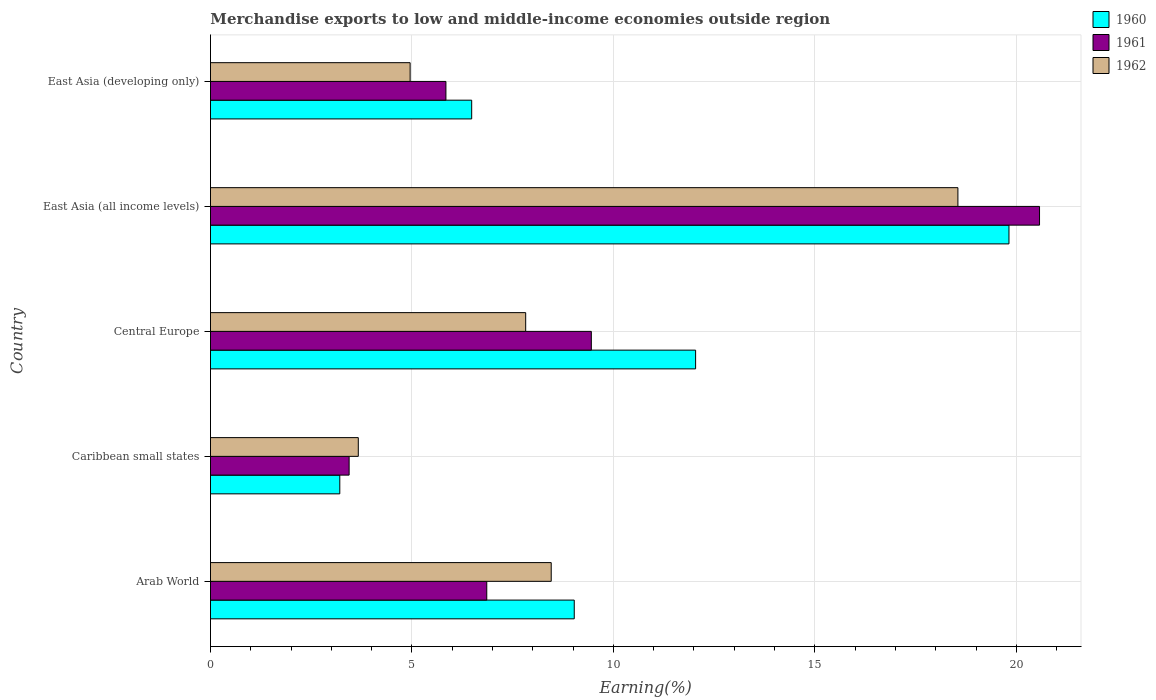How many different coloured bars are there?
Make the answer very short. 3. How many groups of bars are there?
Ensure brevity in your answer.  5. Are the number of bars on each tick of the Y-axis equal?
Your answer should be compact. Yes. What is the label of the 5th group of bars from the top?
Your response must be concise. Arab World. What is the percentage of amount earned from merchandise exports in 1961 in Caribbean small states?
Your answer should be compact. 3.44. Across all countries, what is the maximum percentage of amount earned from merchandise exports in 1962?
Make the answer very short. 18.55. Across all countries, what is the minimum percentage of amount earned from merchandise exports in 1962?
Ensure brevity in your answer.  3.67. In which country was the percentage of amount earned from merchandise exports in 1960 maximum?
Keep it short and to the point. East Asia (all income levels). In which country was the percentage of amount earned from merchandise exports in 1960 minimum?
Offer a terse response. Caribbean small states. What is the total percentage of amount earned from merchandise exports in 1960 in the graph?
Offer a very short reply. 50.58. What is the difference between the percentage of amount earned from merchandise exports in 1960 in Caribbean small states and that in East Asia (developing only)?
Offer a terse response. -3.27. What is the difference between the percentage of amount earned from merchandise exports in 1960 in Arab World and the percentage of amount earned from merchandise exports in 1961 in East Asia (developing only)?
Offer a terse response. 3.19. What is the average percentage of amount earned from merchandise exports in 1962 per country?
Make the answer very short. 8.69. What is the difference between the percentage of amount earned from merchandise exports in 1960 and percentage of amount earned from merchandise exports in 1962 in East Asia (developing only)?
Offer a very short reply. 1.53. What is the ratio of the percentage of amount earned from merchandise exports in 1960 in East Asia (all income levels) to that in East Asia (developing only)?
Give a very brief answer. 3.06. Is the difference between the percentage of amount earned from merchandise exports in 1960 in Arab World and East Asia (developing only) greater than the difference between the percentage of amount earned from merchandise exports in 1962 in Arab World and East Asia (developing only)?
Your response must be concise. No. What is the difference between the highest and the second highest percentage of amount earned from merchandise exports in 1962?
Provide a succinct answer. 10.09. What is the difference between the highest and the lowest percentage of amount earned from merchandise exports in 1960?
Offer a terse response. 16.61. What does the 1st bar from the top in Arab World represents?
Your answer should be compact. 1962. Is it the case that in every country, the sum of the percentage of amount earned from merchandise exports in 1960 and percentage of amount earned from merchandise exports in 1962 is greater than the percentage of amount earned from merchandise exports in 1961?
Make the answer very short. Yes. How many bars are there?
Your answer should be compact. 15. Are all the bars in the graph horizontal?
Provide a short and direct response. Yes. What is the difference between two consecutive major ticks on the X-axis?
Make the answer very short. 5. Are the values on the major ticks of X-axis written in scientific E-notation?
Offer a very short reply. No. Does the graph contain any zero values?
Keep it short and to the point. No. How are the legend labels stacked?
Give a very brief answer. Vertical. What is the title of the graph?
Offer a terse response. Merchandise exports to low and middle-income economies outside region. What is the label or title of the X-axis?
Your answer should be very brief. Earning(%). What is the Earning(%) of 1960 in Arab World?
Provide a short and direct response. 9.03. What is the Earning(%) of 1961 in Arab World?
Your response must be concise. 6.86. What is the Earning(%) of 1962 in Arab World?
Provide a succinct answer. 8.46. What is the Earning(%) of 1960 in Caribbean small states?
Your answer should be very brief. 3.21. What is the Earning(%) of 1961 in Caribbean small states?
Keep it short and to the point. 3.44. What is the Earning(%) of 1962 in Caribbean small states?
Provide a short and direct response. 3.67. What is the Earning(%) in 1960 in Central Europe?
Offer a very short reply. 12.04. What is the Earning(%) of 1961 in Central Europe?
Provide a succinct answer. 9.45. What is the Earning(%) of 1962 in Central Europe?
Your answer should be compact. 7.82. What is the Earning(%) in 1960 in East Asia (all income levels)?
Give a very brief answer. 19.82. What is the Earning(%) of 1961 in East Asia (all income levels)?
Offer a terse response. 20.58. What is the Earning(%) in 1962 in East Asia (all income levels)?
Provide a succinct answer. 18.55. What is the Earning(%) of 1960 in East Asia (developing only)?
Ensure brevity in your answer.  6.48. What is the Earning(%) in 1961 in East Asia (developing only)?
Your answer should be compact. 5.84. What is the Earning(%) in 1962 in East Asia (developing only)?
Keep it short and to the point. 4.96. Across all countries, what is the maximum Earning(%) in 1960?
Offer a very short reply. 19.82. Across all countries, what is the maximum Earning(%) of 1961?
Provide a succinct answer. 20.58. Across all countries, what is the maximum Earning(%) in 1962?
Your answer should be very brief. 18.55. Across all countries, what is the minimum Earning(%) of 1960?
Provide a succinct answer. 3.21. Across all countries, what is the minimum Earning(%) in 1961?
Offer a very short reply. 3.44. Across all countries, what is the minimum Earning(%) of 1962?
Your answer should be very brief. 3.67. What is the total Earning(%) in 1960 in the graph?
Your response must be concise. 50.58. What is the total Earning(%) of 1961 in the graph?
Provide a succinct answer. 46.17. What is the total Earning(%) of 1962 in the graph?
Your answer should be compact. 43.46. What is the difference between the Earning(%) of 1960 in Arab World and that in Caribbean small states?
Keep it short and to the point. 5.82. What is the difference between the Earning(%) of 1961 in Arab World and that in Caribbean small states?
Offer a terse response. 3.42. What is the difference between the Earning(%) in 1962 in Arab World and that in Caribbean small states?
Give a very brief answer. 4.79. What is the difference between the Earning(%) of 1960 in Arab World and that in Central Europe?
Your answer should be very brief. -3.01. What is the difference between the Earning(%) in 1961 in Arab World and that in Central Europe?
Provide a short and direct response. -2.6. What is the difference between the Earning(%) of 1962 in Arab World and that in Central Europe?
Your response must be concise. 0.63. What is the difference between the Earning(%) in 1960 in Arab World and that in East Asia (all income levels)?
Provide a short and direct response. -10.79. What is the difference between the Earning(%) of 1961 in Arab World and that in East Asia (all income levels)?
Provide a succinct answer. -13.72. What is the difference between the Earning(%) of 1962 in Arab World and that in East Asia (all income levels)?
Offer a very short reply. -10.09. What is the difference between the Earning(%) in 1960 in Arab World and that in East Asia (developing only)?
Give a very brief answer. 2.55. What is the difference between the Earning(%) of 1961 in Arab World and that in East Asia (developing only)?
Offer a terse response. 1.01. What is the difference between the Earning(%) of 1962 in Arab World and that in East Asia (developing only)?
Keep it short and to the point. 3.5. What is the difference between the Earning(%) in 1960 in Caribbean small states and that in Central Europe?
Your answer should be very brief. -8.83. What is the difference between the Earning(%) of 1961 in Caribbean small states and that in Central Europe?
Your response must be concise. -6.01. What is the difference between the Earning(%) of 1962 in Caribbean small states and that in Central Europe?
Offer a terse response. -4.15. What is the difference between the Earning(%) of 1960 in Caribbean small states and that in East Asia (all income levels)?
Your response must be concise. -16.61. What is the difference between the Earning(%) of 1961 in Caribbean small states and that in East Asia (all income levels)?
Give a very brief answer. -17.14. What is the difference between the Earning(%) of 1962 in Caribbean small states and that in East Asia (all income levels)?
Make the answer very short. -14.88. What is the difference between the Earning(%) of 1960 in Caribbean small states and that in East Asia (developing only)?
Your answer should be very brief. -3.27. What is the difference between the Earning(%) of 1961 in Caribbean small states and that in East Asia (developing only)?
Offer a very short reply. -2.4. What is the difference between the Earning(%) of 1962 in Caribbean small states and that in East Asia (developing only)?
Keep it short and to the point. -1.29. What is the difference between the Earning(%) of 1960 in Central Europe and that in East Asia (all income levels)?
Your answer should be very brief. -7.78. What is the difference between the Earning(%) of 1961 in Central Europe and that in East Asia (all income levels)?
Your answer should be compact. -11.12. What is the difference between the Earning(%) in 1962 in Central Europe and that in East Asia (all income levels)?
Keep it short and to the point. -10.73. What is the difference between the Earning(%) in 1960 in Central Europe and that in East Asia (developing only)?
Your response must be concise. 5.56. What is the difference between the Earning(%) in 1961 in Central Europe and that in East Asia (developing only)?
Provide a short and direct response. 3.61. What is the difference between the Earning(%) of 1962 in Central Europe and that in East Asia (developing only)?
Give a very brief answer. 2.87. What is the difference between the Earning(%) of 1960 in East Asia (all income levels) and that in East Asia (developing only)?
Offer a very short reply. 13.33. What is the difference between the Earning(%) in 1961 in East Asia (all income levels) and that in East Asia (developing only)?
Offer a very short reply. 14.73. What is the difference between the Earning(%) in 1962 in East Asia (all income levels) and that in East Asia (developing only)?
Your response must be concise. 13.6. What is the difference between the Earning(%) of 1960 in Arab World and the Earning(%) of 1961 in Caribbean small states?
Provide a short and direct response. 5.59. What is the difference between the Earning(%) of 1960 in Arab World and the Earning(%) of 1962 in Caribbean small states?
Offer a terse response. 5.36. What is the difference between the Earning(%) in 1961 in Arab World and the Earning(%) in 1962 in Caribbean small states?
Make the answer very short. 3.19. What is the difference between the Earning(%) of 1960 in Arab World and the Earning(%) of 1961 in Central Europe?
Your response must be concise. -0.42. What is the difference between the Earning(%) of 1960 in Arab World and the Earning(%) of 1962 in Central Europe?
Your answer should be compact. 1.21. What is the difference between the Earning(%) of 1961 in Arab World and the Earning(%) of 1962 in Central Europe?
Your answer should be very brief. -0.97. What is the difference between the Earning(%) in 1960 in Arab World and the Earning(%) in 1961 in East Asia (all income levels)?
Your answer should be very brief. -11.55. What is the difference between the Earning(%) of 1960 in Arab World and the Earning(%) of 1962 in East Asia (all income levels)?
Offer a very short reply. -9.52. What is the difference between the Earning(%) of 1961 in Arab World and the Earning(%) of 1962 in East Asia (all income levels)?
Offer a very short reply. -11.69. What is the difference between the Earning(%) in 1960 in Arab World and the Earning(%) in 1961 in East Asia (developing only)?
Ensure brevity in your answer.  3.19. What is the difference between the Earning(%) of 1960 in Arab World and the Earning(%) of 1962 in East Asia (developing only)?
Your answer should be compact. 4.07. What is the difference between the Earning(%) in 1961 in Arab World and the Earning(%) in 1962 in East Asia (developing only)?
Offer a terse response. 1.9. What is the difference between the Earning(%) of 1960 in Caribbean small states and the Earning(%) of 1961 in Central Europe?
Make the answer very short. -6.24. What is the difference between the Earning(%) of 1960 in Caribbean small states and the Earning(%) of 1962 in Central Europe?
Your answer should be compact. -4.61. What is the difference between the Earning(%) of 1961 in Caribbean small states and the Earning(%) of 1962 in Central Europe?
Make the answer very short. -4.38. What is the difference between the Earning(%) of 1960 in Caribbean small states and the Earning(%) of 1961 in East Asia (all income levels)?
Make the answer very short. -17.37. What is the difference between the Earning(%) of 1960 in Caribbean small states and the Earning(%) of 1962 in East Asia (all income levels)?
Offer a very short reply. -15.34. What is the difference between the Earning(%) of 1961 in Caribbean small states and the Earning(%) of 1962 in East Asia (all income levels)?
Keep it short and to the point. -15.11. What is the difference between the Earning(%) in 1960 in Caribbean small states and the Earning(%) in 1961 in East Asia (developing only)?
Your answer should be very brief. -2.63. What is the difference between the Earning(%) in 1960 in Caribbean small states and the Earning(%) in 1962 in East Asia (developing only)?
Provide a short and direct response. -1.75. What is the difference between the Earning(%) in 1961 in Caribbean small states and the Earning(%) in 1962 in East Asia (developing only)?
Your response must be concise. -1.51. What is the difference between the Earning(%) in 1960 in Central Europe and the Earning(%) in 1961 in East Asia (all income levels)?
Your response must be concise. -8.54. What is the difference between the Earning(%) in 1960 in Central Europe and the Earning(%) in 1962 in East Asia (all income levels)?
Give a very brief answer. -6.51. What is the difference between the Earning(%) in 1961 in Central Europe and the Earning(%) in 1962 in East Asia (all income levels)?
Ensure brevity in your answer.  -9.1. What is the difference between the Earning(%) of 1960 in Central Europe and the Earning(%) of 1961 in East Asia (developing only)?
Your answer should be very brief. 6.2. What is the difference between the Earning(%) in 1960 in Central Europe and the Earning(%) in 1962 in East Asia (developing only)?
Offer a terse response. 7.09. What is the difference between the Earning(%) in 1961 in Central Europe and the Earning(%) in 1962 in East Asia (developing only)?
Provide a succinct answer. 4.5. What is the difference between the Earning(%) of 1960 in East Asia (all income levels) and the Earning(%) of 1961 in East Asia (developing only)?
Your answer should be very brief. 13.97. What is the difference between the Earning(%) in 1960 in East Asia (all income levels) and the Earning(%) in 1962 in East Asia (developing only)?
Provide a short and direct response. 14.86. What is the difference between the Earning(%) of 1961 in East Asia (all income levels) and the Earning(%) of 1962 in East Asia (developing only)?
Make the answer very short. 15.62. What is the average Earning(%) in 1960 per country?
Give a very brief answer. 10.12. What is the average Earning(%) in 1961 per country?
Keep it short and to the point. 9.23. What is the average Earning(%) in 1962 per country?
Give a very brief answer. 8.69. What is the difference between the Earning(%) in 1960 and Earning(%) in 1961 in Arab World?
Your response must be concise. 2.17. What is the difference between the Earning(%) in 1960 and Earning(%) in 1962 in Arab World?
Offer a terse response. 0.57. What is the difference between the Earning(%) in 1961 and Earning(%) in 1962 in Arab World?
Give a very brief answer. -1.6. What is the difference between the Earning(%) in 1960 and Earning(%) in 1961 in Caribbean small states?
Ensure brevity in your answer.  -0.23. What is the difference between the Earning(%) of 1960 and Earning(%) of 1962 in Caribbean small states?
Offer a terse response. -0.46. What is the difference between the Earning(%) of 1961 and Earning(%) of 1962 in Caribbean small states?
Your answer should be very brief. -0.23. What is the difference between the Earning(%) of 1960 and Earning(%) of 1961 in Central Europe?
Provide a succinct answer. 2.59. What is the difference between the Earning(%) of 1960 and Earning(%) of 1962 in Central Europe?
Your answer should be compact. 4.22. What is the difference between the Earning(%) of 1961 and Earning(%) of 1962 in Central Europe?
Your answer should be compact. 1.63. What is the difference between the Earning(%) in 1960 and Earning(%) in 1961 in East Asia (all income levels)?
Provide a succinct answer. -0.76. What is the difference between the Earning(%) in 1960 and Earning(%) in 1962 in East Asia (all income levels)?
Keep it short and to the point. 1.27. What is the difference between the Earning(%) in 1961 and Earning(%) in 1962 in East Asia (all income levels)?
Offer a terse response. 2.03. What is the difference between the Earning(%) of 1960 and Earning(%) of 1961 in East Asia (developing only)?
Your response must be concise. 0.64. What is the difference between the Earning(%) in 1960 and Earning(%) in 1962 in East Asia (developing only)?
Your response must be concise. 1.53. What is the difference between the Earning(%) of 1961 and Earning(%) of 1962 in East Asia (developing only)?
Offer a terse response. 0.89. What is the ratio of the Earning(%) of 1960 in Arab World to that in Caribbean small states?
Offer a very short reply. 2.81. What is the ratio of the Earning(%) of 1961 in Arab World to that in Caribbean small states?
Keep it short and to the point. 1.99. What is the ratio of the Earning(%) of 1962 in Arab World to that in Caribbean small states?
Offer a very short reply. 2.31. What is the ratio of the Earning(%) of 1960 in Arab World to that in Central Europe?
Your answer should be compact. 0.75. What is the ratio of the Earning(%) in 1961 in Arab World to that in Central Europe?
Your answer should be compact. 0.73. What is the ratio of the Earning(%) of 1962 in Arab World to that in Central Europe?
Provide a succinct answer. 1.08. What is the ratio of the Earning(%) in 1960 in Arab World to that in East Asia (all income levels)?
Offer a terse response. 0.46. What is the ratio of the Earning(%) of 1962 in Arab World to that in East Asia (all income levels)?
Make the answer very short. 0.46. What is the ratio of the Earning(%) of 1960 in Arab World to that in East Asia (developing only)?
Your answer should be compact. 1.39. What is the ratio of the Earning(%) of 1961 in Arab World to that in East Asia (developing only)?
Provide a succinct answer. 1.17. What is the ratio of the Earning(%) in 1962 in Arab World to that in East Asia (developing only)?
Give a very brief answer. 1.71. What is the ratio of the Earning(%) in 1960 in Caribbean small states to that in Central Europe?
Your answer should be compact. 0.27. What is the ratio of the Earning(%) of 1961 in Caribbean small states to that in Central Europe?
Provide a succinct answer. 0.36. What is the ratio of the Earning(%) of 1962 in Caribbean small states to that in Central Europe?
Keep it short and to the point. 0.47. What is the ratio of the Earning(%) in 1960 in Caribbean small states to that in East Asia (all income levels)?
Provide a short and direct response. 0.16. What is the ratio of the Earning(%) in 1961 in Caribbean small states to that in East Asia (all income levels)?
Offer a terse response. 0.17. What is the ratio of the Earning(%) in 1962 in Caribbean small states to that in East Asia (all income levels)?
Your answer should be compact. 0.2. What is the ratio of the Earning(%) in 1960 in Caribbean small states to that in East Asia (developing only)?
Provide a succinct answer. 0.5. What is the ratio of the Earning(%) of 1961 in Caribbean small states to that in East Asia (developing only)?
Offer a very short reply. 0.59. What is the ratio of the Earning(%) in 1962 in Caribbean small states to that in East Asia (developing only)?
Ensure brevity in your answer.  0.74. What is the ratio of the Earning(%) in 1960 in Central Europe to that in East Asia (all income levels)?
Keep it short and to the point. 0.61. What is the ratio of the Earning(%) in 1961 in Central Europe to that in East Asia (all income levels)?
Your answer should be compact. 0.46. What is the ratio of the Earning(%) of 1962 in Central Europe to that in East Asia (all income levels)?
Give a very brief answer. 0.42. What is the ratio of the Earning(%) in 1960 in Central Europe to that in East Asia (developing only)?
Your answer should be very brief. 1.86. What is the ratio of the Earning(%) in 1961 in Central Europe to that in East Asia (developing only)?
Ensure brevity in your answer.  1.62. What is the ratio of the Earning(%) of 1962 in Central Europe to that in East Asia (developing only)?
Offer a very short reply. 1.58. What is the ratio of the Earning(%) of 1960 in East Asia (all income levels) to that in East Asia (developing only)?
Your answer should be compact. 3.06. What is the ratio of the Earning(%) in 1961 in East Asia (all income levels) to that in East Asia (developing only)?
Your answer should be compact. 3.52. What is the ratio of the Earning(%) of 1962 in East Asia (all income levels) to that in East Asia (developing only)?
Give a very brief answer. 3.74. What is the difference between the highest and the second highest Earning(%) in 1960?
Give a very brief answer. 7.78. What is the difference between the highest and the second highest Earning(%) in 1961?
Provide a short and direct response. 11.12. What is the difference between the highest and the second highest Earning(%) in 1962?
Provide a short and direct response. 10.09. What is the difference between the highest and the lowest Earning(%) of 1960?
Offer a terse response. 16.61. What is the difference between the highest and the lowest Earning(%) in 1961?
Ensure brevity in your answer.  17.14. What is the difference between the highest and the lowest Earning(%) of 1962?
Keep it short and to the point. 14.88. 